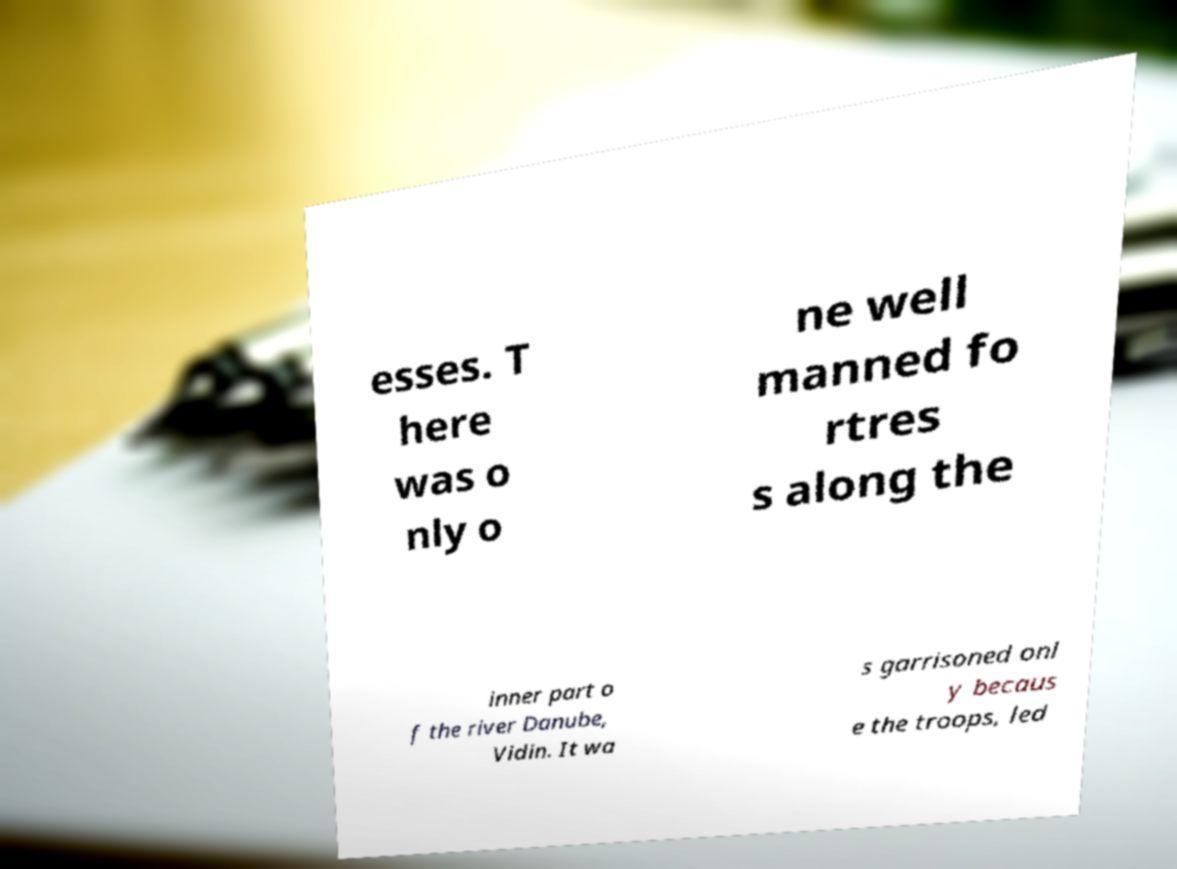Could you extract and type out the text from this image? esses. T here was o nly o ne well manned fo rtres s along the inner part o f the river Danube, Vidin. It wa s garrisoned onl y becaus e the troops, led 